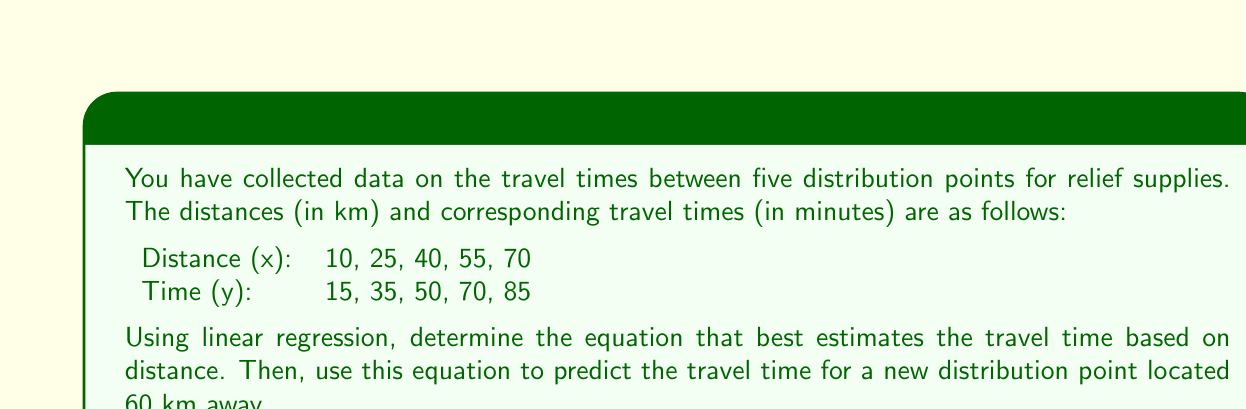Help me with this question. To solve this problem, we'll use linear regression to find the best-fit line $y = mx + b$, where $y$ is the travel time and $x$ is the distance.

Step 1: Calculate the means of x and y
$\bar{x} = \frac{10 + 25 + 40 + 55 + 70}{5} = 40$
$\bar{y} = \frac{15 + 35 + 50 + 70 + 85}{5} = 51$

Step 2: Calculate the slope (m) using the formula:
$m = \frac{\sum(x_i - \bar{x})(y_i - \bar{y})}{\sum(x_i - \bar{x})^2}$

$\sum(x_i - \bar{x})(y_i - \bar{y}) = (-30)(-36) + (-15)(-16) + (0)(-1) + (15)(19) + (30)(34) = 2400$
$\sum(x_i - \bar{x})^2 = (-30)^2 + (-15)^2 + (0)^2 + (15)^2 + (30)^2 = 1800$

$m = \frac{2400}{1800} = \frac{4}{3} \approx 1.33$

Step 3: Calculate the y-intercept (b) using the formula:
$b = \bar{y} - m\bar{x}$
$b = 51 - \frac{4}{3}(40) = 51 - 53.33 = -2.33$

Step 4: Write the regression equation:
$y = 1.33x - 2.33$

Step 5: Predict the travel time for a distance of 60 km:
$y = 1.33(60) - 2.33 = 77.47$

Therefore, the estimated travel time for a distribution point 60 km away is approximately 77.47 minutes.
Answer: 77.47 minutes 